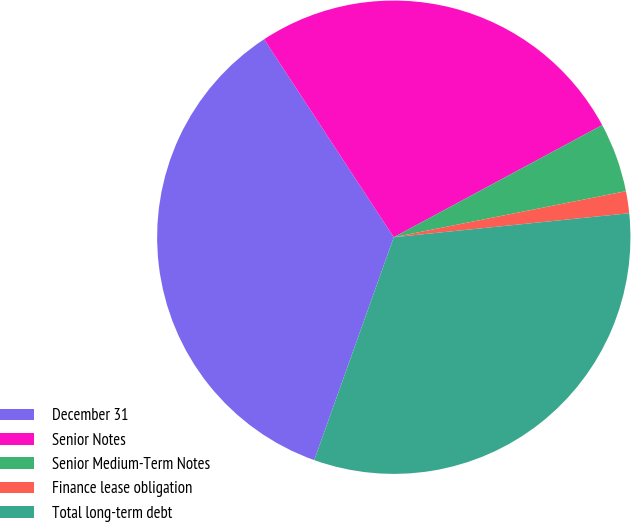Convert chart to OTSL. <chart><loc_0><loc_0><loc_500><loc_500><pie_chart><fcel>December 31<fcel>Senior Notes<fcel>Senior Medium-Term Notes<fcel>Finance lease obligation<fcel>Total long-term debt<nl><fcel>35.31%<fcel>26.37%<fcel>4.74%<fcel>1.5%<fcel>32.07%<nl></chart> 